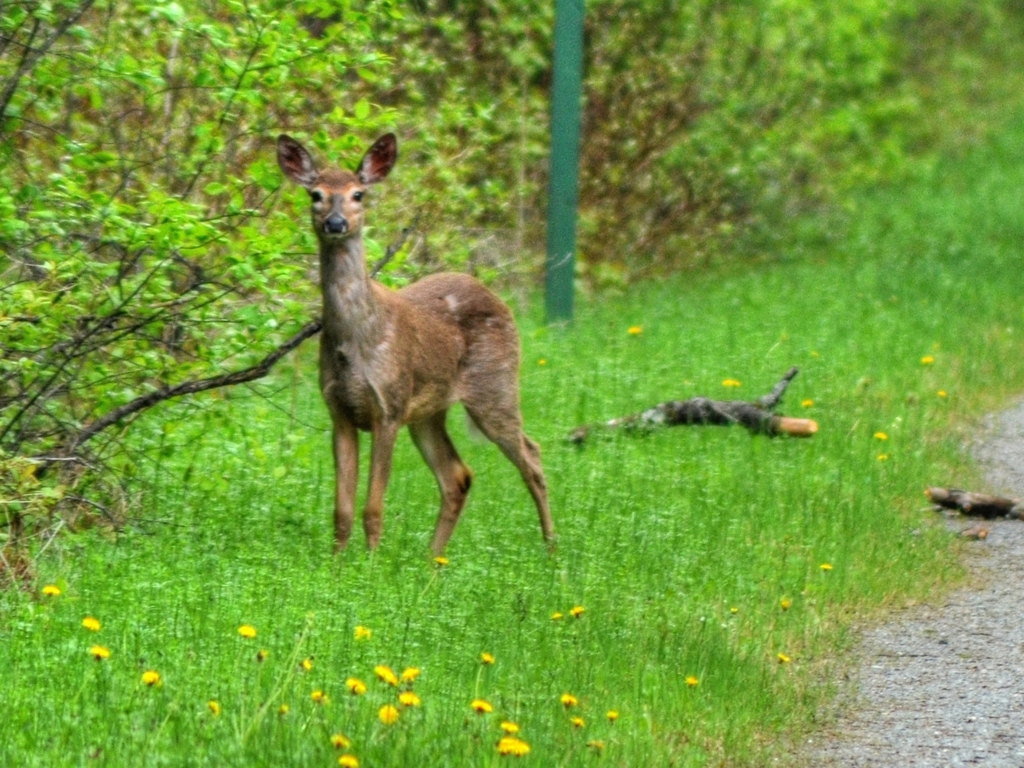What species is the animal in the image, and can you tell if it's an adult or a juvenile? The animal in the image is a deer. Based on its size and physical characteristics, it looks like an adult. You can typically tell the age of a deer by its size and the development of its antlers if it's a male, although the lack of visible antlers here does not necessarily indicate it's a female or juvenile since the image resolution limits detailed observations. 